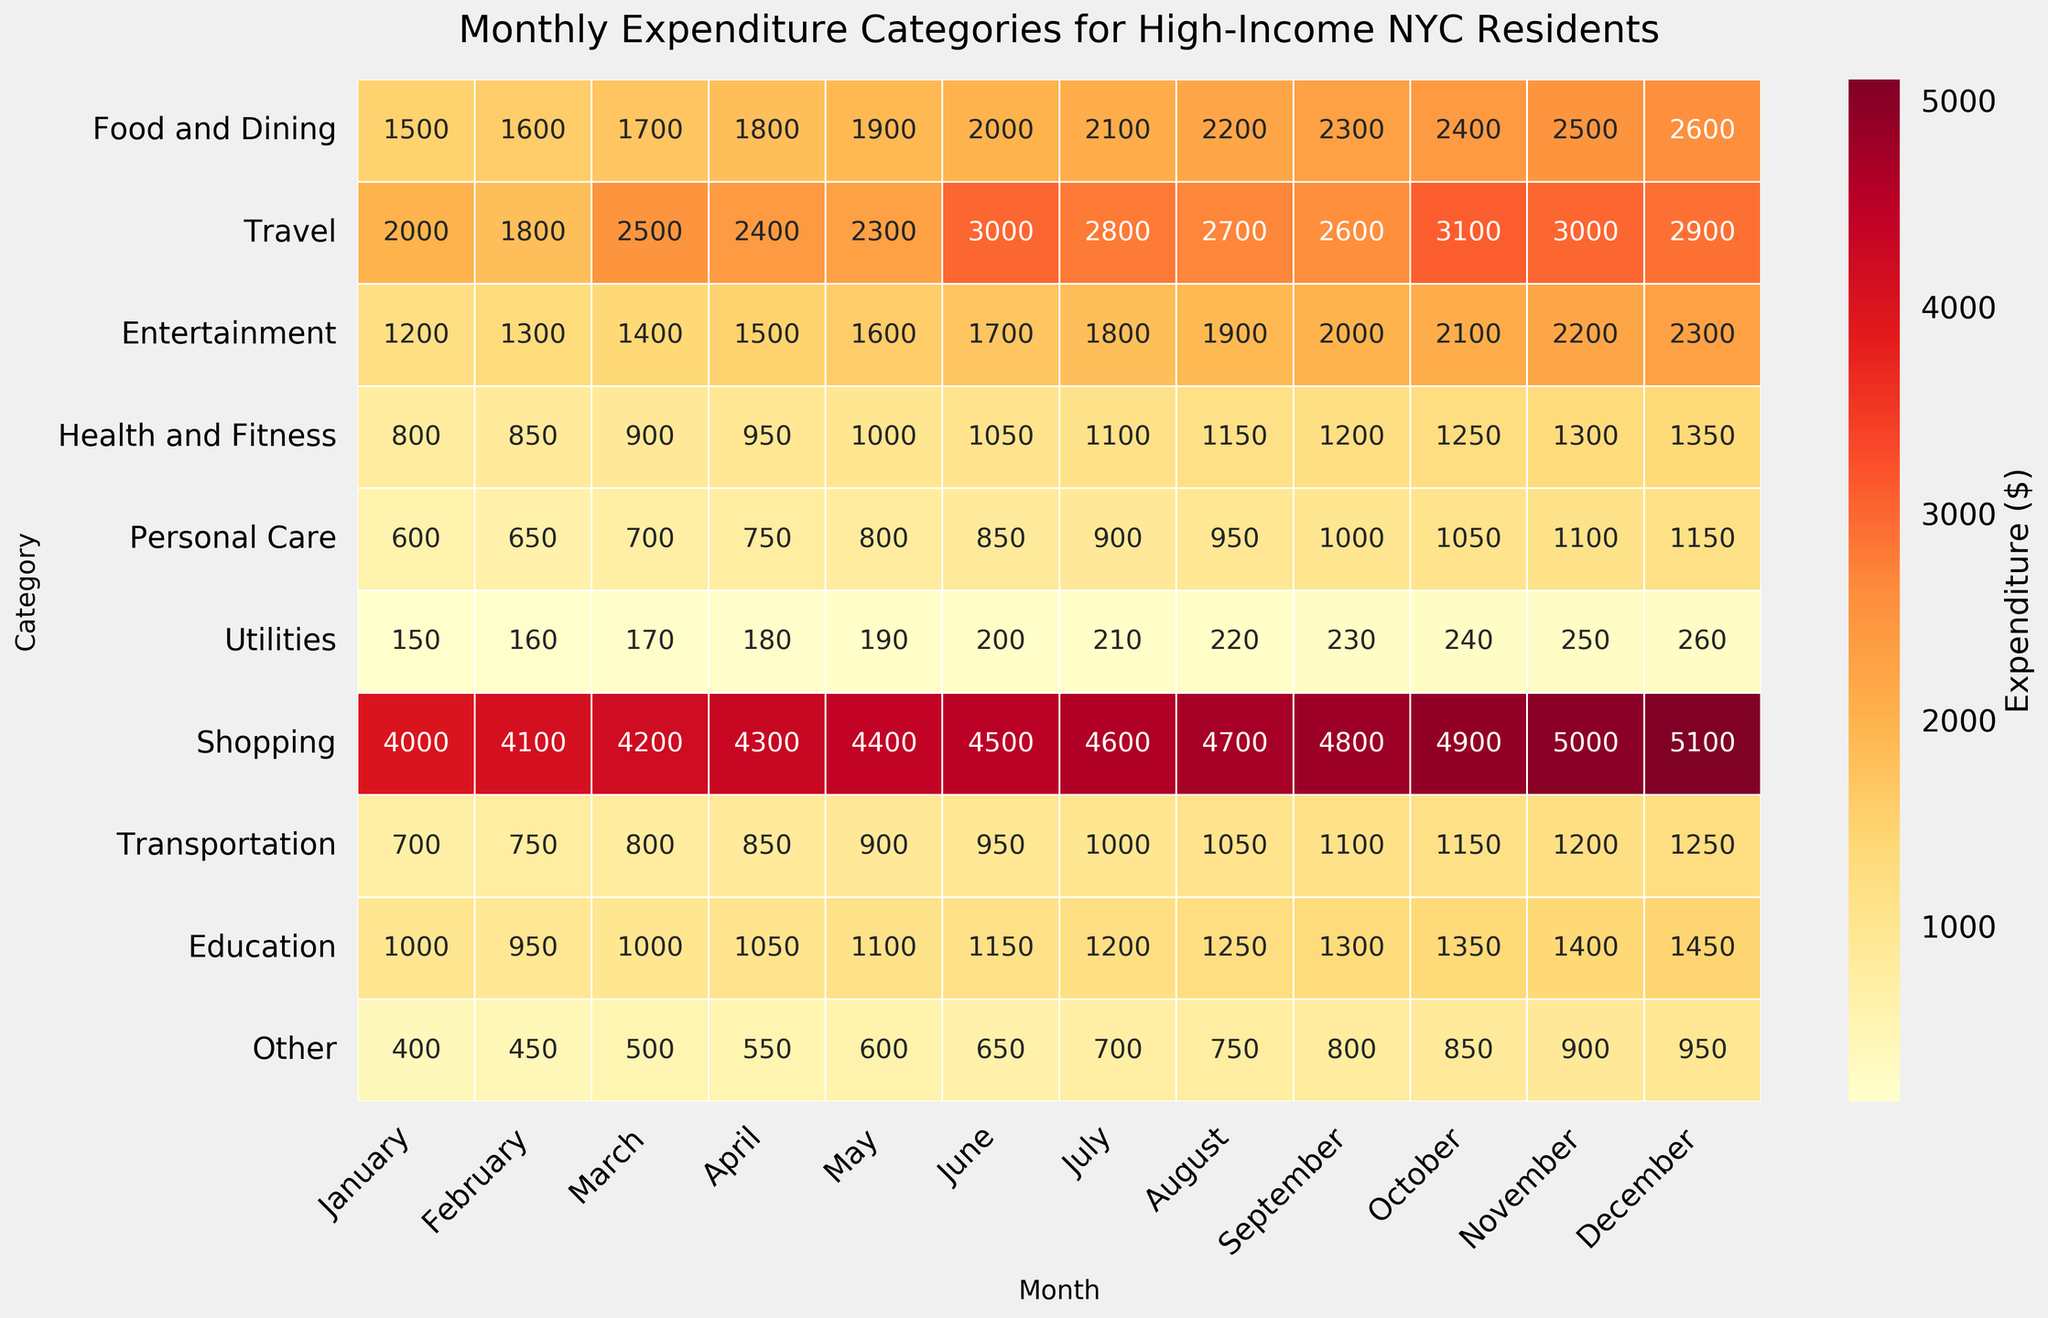What is the title of the heatmap? The title is typically located at the top of the heatmap. Here, it reads "Monthly Expenditure Categories for High-Income NYC Residents."
Answer: Monthly Expenditure Categories for High-Income NYC Residents How much was spent on Travel in June? Locate the row for 'Travel' and the column for 'June' in the heatmap. The intersecting cell shows the expenditure.
Answer: 3000 Which month showed the highest expenditure on Utilities? Scan the 'Utilities' row and identify the highest value. The highest expenditure appears in December.
Answer: December What is the average monthly expenditure on Health and Fitness from January to March? Sum the expenditures from January to March for Health and Fitness (800 + 850 + 900 = 2550) and divide by 3 to find the average.
Answer: 850 How does the spending on Education in September compare to that in April? Compare the values in the 'Education' row for September (1300) and April (1050). September's value is higher than April's.
Answer: September is higher Which category has the most significant increase from January to December? Identify the category with the lowest value in January and compare it with the highest value in December. 'Personal Care' increased from 600 in January to 1150 in December.
Answer: Personal Care What is the difference in expenditure on Food and Dining between February and October? Subtract the expenditure in February (1600) from that in October (2400). The result is 800.
Answer: 800 Which month had the lowest expenditure on 'Other' categories? Identify the lowest value in the 'Other' row. The lowest expenditure, 400, was in January.
Answer: January What is the total expenditure for 'Shopping' in the second quarter (April, May, June)? Sum the expenditures for 'Shopping' in April, May, and June (4300 + 4400 + 4500 = 13200).
Answer: 13200 What trend can you observe in the 'Entertainment' category throughout the year? Observe the values for 'Entertainment' from January to December. The expenditures generally increase each month, indicating an upward trend.
Answer: Upward trend 